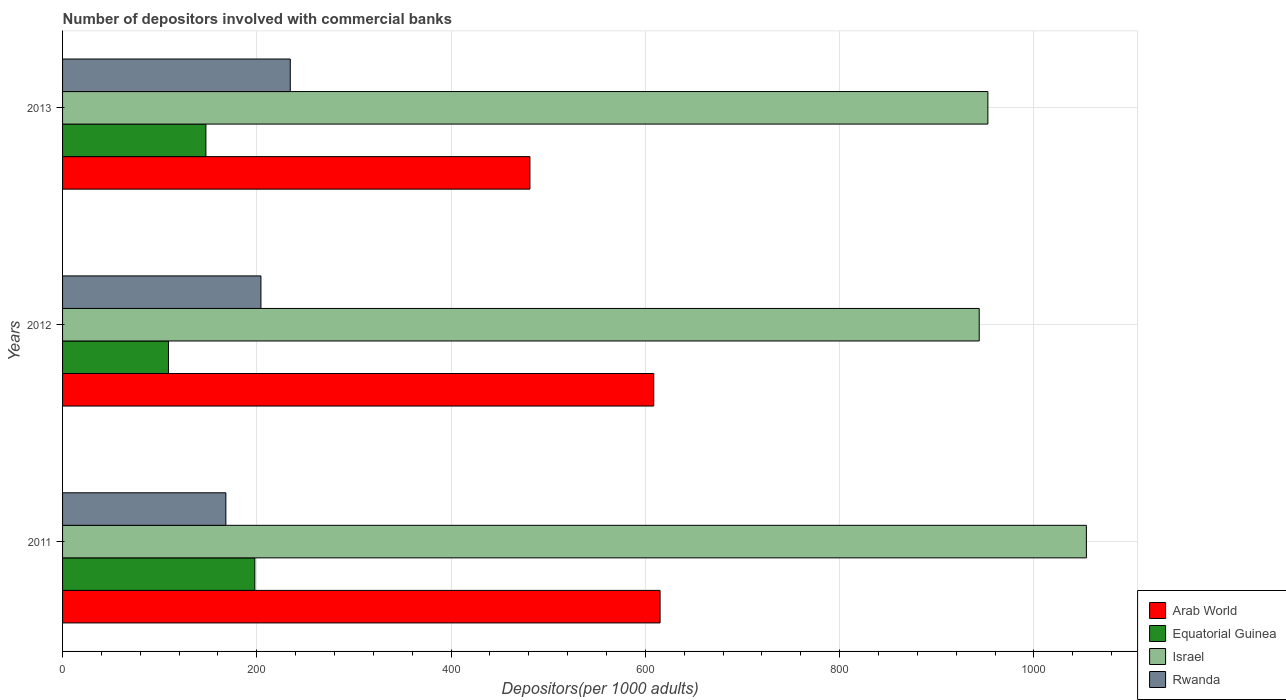How many different coloured bars are there?
Keep it short and to the point. 4. Are the number of bars per tick equal to the number of legend labels?
Ensure brevity in your answer.  Yes. Are the number of bars on each tick of the Y-axis equal?
Your answer should be compact. Yes. How many bars are there on the 3rd tick from the bottom?
Offer a very short reply. 4. What is the number of depositors involved with commercial banks in Rwanda in 2011?
Your answer should be very brief. 168.11. Across all years, what is the maximum number of depositors involved with commercial banks in Rwanda?
Ensure brevity in your answer.  234.42. Across all years, what is the minimum number of depositors involved with commercial banks in Arab World?
Provide a short and direct response. 481.17. In which year was the number of depositors involved with commercial banks in Equatorial Guinea maximum?
Keep it short and to the point. 2011. In which year was the number of depositors involved with commercial banks in Arab World minimum?
Your response must be concise. 2013. What is the total number of depositors involved with commercial banks in Arab World in the graph?
Offer a very short reply. 1704.97. What is the difference between the number of depositors involved with commercial banks in Arab World in 2011 and that in 2012?
Provide a short and direct response. 6.52. What is the difference between the number of depositors involved with commercial banks in Equatorial Guinea in 2011 and the number of depositors involved with commercial banks in Israel in 2012?
Your response must be concise. -745.76. What is the average number of depositors involved with commercial banks in Arab World per year?
Make the answer very short. 568.32. In the year 2013, what is the difference between the number of depositors involved with commercial banks in Israel and number of depositors involved with commercial banks in Rwanda?
Give a very brief answer. 718.2. What is the ratio of the number of depositors involved with commercial banks in Arab World in 2011 to that in 2013?
Offer a terse response. 1.28. Is the number of depositors involved with commercial banks in Israel in 2012 less than that in 2013?
Give a very brief answer. Yes. Is the difference between the number of depositors involved with commercial banks in Israel in 2011 and 2012 greater than the difference between the number of depositors involved with commercial banks in Rwanda in 2011 and 2012?
Offer a terse response. Yes. What is the difference between the highest and the second highest number of depositors involved with commercial banks in Rwanda?
Offer a terse response. 30.2. What is the difference between the highest and the lowest number of depositors involved with commercial banks in Equatorial Guinea?
Give a very brief answer. 88.94. Is it the case that in every year, the sum of the number of depositors involved with commercial banks in Equatorial Guinea and number of depositors involved with commercial banks in Israel is greater than the sum of number of depositors involved with commercial banks in Arab World and number of depositors involved with commercial banks in Rwanda?
Provide a short and direct response. Yes. What does the 3rd bar from the top in 2013 represents?
Your response must be concise. Equatorial Guinea. What does the 1st bar from the bottom in 2012 represents?
Provide a succinct answer. Arab World. How many years are there in the graph?
Ensure brevity in your answer.  3. Are the values on the major ticks of X-axis written in scientific E-notation?
Keep it short and to the point. No. Does the graph contain any zero values?
Make the answer very short. No. How are the legend labels stacked?
Offer a terse response. Vertical. What is the title of the graph?
Your answer should be very brief. Number of depositors involved with commercial banks. What is the label or title of the X-axis?
Give a very brief answer. Depositors(per 1000 adults). What is the label or title of the Y-axis?
Make the answer very short. Years. What is the Depositors(per 1000 adults) of Arab World in 2011?
Keep it short and to the point. 615.16. What is the Depositors(per 1000 adults) of Equatorial Guinea in 2011?
Keep it short and to the point. 197.96. What is the Depositors(per 1000 adults) of Israel in 2011?
Ensure brevity in your answer.  1054.06. What is the Depositors(per 1000 adults) in Rwanda in 2011?
Offer a very short reply. 168.11. What is the Depositors(per 1000 adults) of Arab World in 2012?
Your answer should be very brief. 608.64. What is the Depositors(per 1000 adults) of Equatorial Guinea in 2012?
Provide a succinct answer. 109.02. What is the Depositors(per 1000 adults) in Israel in 2012?
Ensure brevity in your answer.  943.72. What is the Depositors(per 1000 adults) of Rwanda in 2012?
Your response must be concise. 204.22. What is the Depositors(per 1000 adults) in Arab World in 2013?
Make the answer very short. 481.17. What is the Depositors(per 1000 adults) of Equatorial Guinea in 2013?
Ensure brevity in your answer.  147.57. What is the Depositors(per 1000 adults) of Israel in 2013?
Offer a terse response. 952.62. What is the Depositors(per 1000 adults) of Rwanda in 2013?
Your answer should be very brief. 234.42. Across all years, what is the maximum Depositors(per 1000 adults) in Arab World?
Ensure brevity in your answer.  615.16. Across all years, what is the maximum Depositors(per 1000 adults) of Equatorial Guinea?
Ensure brevity in your answer.  197.96. Across all years, what is the maximum Depositors(per 1000 adults) in Israel?
Provide a short and direct response. 1054.06. Across all years, what is the maximum Depositors(per 1000 adults) in Rwanda?
Your response must be concise. 234.42. Across all years, what is the minimum Depositors(per 1000 adults) of Arab World?
Provide a short and direct response. 481.17. Across all years, what is the minimum Depositors(per 1000 adults) in Equatorial Guinea?
Offer a terse response. 109.02. Across all years, what is the minimum Depositors(per 1000 adults) in Israel?
Keep it short and to the point. 943.72. Across all years, what is the minimum Depositors(per 1000 adults) in Rwanda?
Make the answer very short. 168.11. What is the total Depositors(per 1000 adults) in Arab World in the graph?
Provide a succinct answer. 1704.97. What is the total Depositors(per 1000 adults) of Equatorial Guinea in the graph?
Your response must be concise. 454.55. What is the total Depositors(per 1000 adults) in Israel in the graph?
Ensure brevity in your answer.  2950.4. What is the total Depositors(per 1000 adults) of Rwanda in the graph?
Provide a short and direct response. 606.74. What is the difference between the Depositors(per 1000 adults) in Arab World in 2011 and that in 2012?
Provide a short and direct response. 6.52. What is the difference between the Depositors(per 1000 adults) of Equatorial Guinea in 2011 and that in 2012?
Make the answer very short. 88.94. What is the difference between the Depositors(per 1000 adults) in Israel in 2011 and that in 2012?
Your response must be concise. 110.33. What is the difference between the Depositors(per 1000 adults) of Rwanda in 2011 and that in 2012?
Your answer should be compact. -36.1. What is the difference between the Depositors(per 1000 adults) of Arab World in 2011 and that in 2013?
Your answer should be compact. 133.99. What is the difference between the Depositors(per 1000 adults) in Equatorial Guinea in 2011 and that in 2013?
Ensure brevity in your answer.  50.39. What is the difference between the Depositors(per 1000 adults) in Israel in 2011 and that in 2013?
Keep it short and to the point. 101.44. What is the difference between the Depositors(per 1000 adults) of Rwanda in 2011 and that in 2013?
Provide a succinct answer. -66.31. What is the difference between the Depositors(per 1000 adults) in Arab World in 2012 and that in 2013?
Provide a succinct answer. 127.47. What is the difference between the Depositors(per 1000 adults) in Equatorial Guinea in 2012 and that in 2013?
Offer a terse response. -38.55. What is the difference between the Depositors(per 1000 adults) of Israel in 2012 and that in 2013?
Ensure brevity in your answer.  -8.9. What is the difference between the Depositors(per 1000 adults) in Rwanda in 2012 and that in 2013?
Your answer should be compact. -30.2. What is the difference between the Depositors(per 1000 adults) in Arab World in 2011 and the Depositors(per 1000 adults) in Equatorial Guinea in 2012?
Provide a short and direct response. 506.14. What is the difference between the Depositors(per 1000 adults) of Arab World in 2011 and the Depositors(per 1000 adults) of Israel in 2012?
Keep it short and to the point. -328.57. What is the difference between the Depositors(per 1000 adults) of Arab World in 2011 and the Depositors(per 1000 adults) of Rwanda in 2012?
Your answer should be compact. 410.94. What is the difference between the Depositors(per 1000 adults) of Equatorial Guinea in 2011 and the Depositors(per 1000 adults) of Israel in 2012?
Make the answer very short. -745.76. What is the difference between the Depositors(per 1000 adults) in Equatorial Guinea in 2011 and the Depositors(per 1000 adults) in Rwanda in 2012?
Provide a short and direct response. -6.25. What is the difference between the Depositors(per 1000 adults) of Israel in 2011 and the Depositors(per 1000 adults) of Rwanda in 2012?
Ensure brevity in your answer.  849.84. What is the difference between the Depositors(per 1000 adults) of Arab World in 2011 and the Depositors(per 1000 adults) of Equatorial Guinea in 2013?
Give a very brief answer. 467.59. What is the difference between the Depositors(per 1000 adults) of Arab World in 2011 and the Depositors(per 1000 adults) of Israel in 2013?
Keep it short and to the point. -337.46. What is the difference between the Depositors(per 1000 adults) in Arab World in 2011 and the Depositors(per 1000 adults) in Rwanda in 2013?
Give a very brief answer. 380.74. What is the difference between the Depositors(per 1000 adults) of Equatorial Guinea in 2011 and the Depositors(per 1000 adults) of Israel in 2013?
Offer a terse response. -754.66. What is the difference between the Depositors(per 1000 adults) of Equatorial Guinea in 2011 and the Depositors(per 1000 adults) of Rwanda in 2013?
Your response must be concise. -36.46. What is the difference between the Depositors(per 1000 adults) in Israel in 2011 and the Depositors(per 1000 adults) in Rwanda in 2013?
Offer a terse response. 819.64. What is the difference between the Depositors(per 1000 adults) of Arab World in 2012 and the Depositors(per 1000 adults) of Equatorial Guinea in 2013?
Offer a terse response. 461.07. What is the difference between the Depositors(per 1000 adults) of Arab World in 2012 and the Depositors(per 1000 adults) of Israel in 2013?
Offer a terse response. -343.98. What is the difference between the Depositors(per 1000 adults) of Arab World in 2012 and the Depositors(per 1000 adults) of Rwanda in 2013?
Your answer should be very brief. 374.22. What is the difference between the Depositors(per 1000 adults) in Equatorial Guinea in 2012 and the Depositors(per 1000 adults) in Israel in 2013?
Give a very brief answer. -843.6. What is the difference between the Depositors(per 1000 adults) of Equatorial Guinea in 2012 and the Depositors(per 1000 adults) of Rwanda in 2013?
Give a very brief answer. -125.4. What is the difference between the Depositors(per 1000 adults) of Israel in 2012 and the Depositors(per 1000 adults) of Rwanda in 2013?
Provide a short and direct response. 709.31. What is the average Depositors(per 1000 adults) in Arab World per year?
Provide a succinct answer. 568.32. What is the average Depositors(per 1000 adults) of Equatorial Guinea per year?
Offer a very short reply. 151.52. What is the average Depositors(per 1000 adults) in Israel per year?
Provide a succinct answer. 983.47. What is the average Depositors(per 1000 adults) of Rwanda per year?
Provide a succinct answer. 202.25. In the year 2011, what is the difference between the Depositors(per 1000 adults) in Arab World and Depositors(per 1000 adults) in Equatorial Guinea?
Provide a short and direct response. 417.2. In the year 2011, what is the difference between the Depositors(per 1000 adults) of Arab World and Depositors(per 1000 adults) of Israel?
Provide a succinct answer. -438.9. In the year 2011, what is the difference between the Depositors(per 1000 adults) in Arab World and Depositors(per 1000 adults) in Rwanda?
Provide a succinct answer. 447.05. In the year 2011, what is the difference between the Depositors(per 1000 adults) in Equatorial Guinea and Depositors(per 1000 adults) in Israel?
Provide a short and direct response. -856.1. In the year 2011, what is the difference between the Depositors(per 1000 adults) of Equatorial Guinea and Depositors(per 1000 adults) of Rwanda?
Ensure brevity in your answer.  29.85. In the year 2011, what is the difference between the Depositors(per 1000 adults) in Israel and Depositors(per 1000 adults) in Rwanda?
Offer a terse response. 885.95. In the year 2012, what is the difference between the Depositors(per 1000 adults) in Arab World and Depositors(per 1000 adults) in Equatorial Guinea?
Keep it short and to the point. 499.62. In the year 2012, what is the difference between the Depositors(per 1000 adults) in Arab World and Depositors(per 1000 adults) in Israel?
Offer a very short reply. -335.08. In the year 2012, what is the difference between the Depositors(per 1000 adults) of Arab World and Depositors(per 1000 adults) of Rwanda?
Provide a succinct answer. 404.42. In the year 2012, what is the difference between the Depositors(per 1000 adults) of Equatorial Guinea and Depositors(per 1000 adults) of Israel?
Your answer should be very brief. -834.71. In the year 2012, what is the difference between the Depositors(per 1000 adults) in Equatorial Guinea and Depositors(per 1000 adults) in Rwanda?
Provide a short and direct response. -95.2. In the year 2012, what is the difference between the Depositors(per 1000 adults) of Israel and Depositors(per 1000 adults) of Rwanda?
Provide a succinct answer. 739.51. In the year 2013, what is the difference between the Depositors(per 1000 adults) of Arab World and Depositors(per 1000 adults) of Equatorial Guinea?
Provide a succinct answer. 333.6. In the year 2013, what is the difference between the Depositors(per 1000 adults) of Arab World and Depositors(per 1000 adults) of Israel?
Give a very brief answer. -471.45. In the year 2013, what is the difference between the Depositors(per 1000 adults) in Arab World and Depositors(per 1000 adults) in Rwanda?
Offer a very short reply. 246.75. In the year 2013, what is the difference between the Depositors(per 1000 adults) of Equatorial Guinea and Depositors(per 1000 adults) of Israel?
Offer a terse response. -805.05. In the year 2013, what is the difference between the Depositors(per 1000 adults) in Equatorial Guinea and Depositors(per 1000 adults) in Rwanda?
Offer a very short reply. -86.85. In the year 2013, what is the difference between the Depositors(per 1000 adults) of Israel and Depositors(per 1000 adults) of Rwanda?
Provide a short and direct response. 718.2. What is the ratio of the Depositors(per 1000 adults) of Arab World in 2011 to that in 2012?
Offer a very short reply. 1.01. What is the ratio of the Depositors(per 1000 adults) of Equatorial Guinea in 2011 to that in 2012?
Your answer should be very brief. 1.82. What is the ratio of the Depositors(per 1000 adults) in Israel in 2011 to that in 2012?
Offer a very short reply. 1.12. What is the ratio of the Depositors(per 1000 adults) in Rwanda in 2011 to that in 2012?
Your response must be concise. 0.82. What is the ratio of the Depositors(per 1000 adults) of Arab World in 2011 to that in 2013?
Provide a short and direct response. 1.28. What is the ratio of the Depositors(per 1000 adults) in Equatorial Guinea in 2011 to that in 2013?
Your answer should be very brief. 1.34. What is the ratio of the Depositors(per 1000 adults) of Israel in 2011 to that in 2013?
Keep it short and to the point. 1.11. What is the ratio of the Depositors(per 1000 adults) of Rwanda in 2011 to that in 2013?
Your answer should be compact. 0.72. What is the ratio of the Depositors(per 1000 adults) in Arab World in 2012 to that in 2013?
Make the answer very short. 1.26. What is the ratio of the Depositors(per 1000 adults) in Equatorial Guinea in 2012 to that in 2013?
Your answer should be compact. 0.74. What is the ratio of the Depositors(per 1000 adults) of Rwanda in 2012 to that in 2013?
Provide a short and direct response. 0.87. What is the difference between the highest and the second highest Depositors(per 1000 adults) in Arab World?
Offer a terse response. 6.52. What is the difference between the highest and the second highest Depositors(per 1000 adults) in Equatorial Guinea?
Offer a terse response. 50.39. What is the difference between the highest and the second highest Depositors(per 1000 adults) of Israel?
Provide a short and direct response. 101.44. What is the difference between the highest and the second highest Depositors(per 1000 adults) in Rwanda?
Your answer should be compact. 30.2. What is the difference between the highest and the lowest Depositors(per 1000 adults) in Arab World?
Offer a very short reply. 133.99. What is the difference between the highest and the lowest Depositors(per 1000 adults) of Equatorial Guinea?
Your answer should be compact. 88.94. What is the difference between the highest and the lowest Depositors(per 1000 adults) in Israel?
Your answer should be compact. 110.33. What is the difference between the highest and the lowest Depositors(per 1000 adults) in Rwanda?
Your answer should be compact. 66.31. 